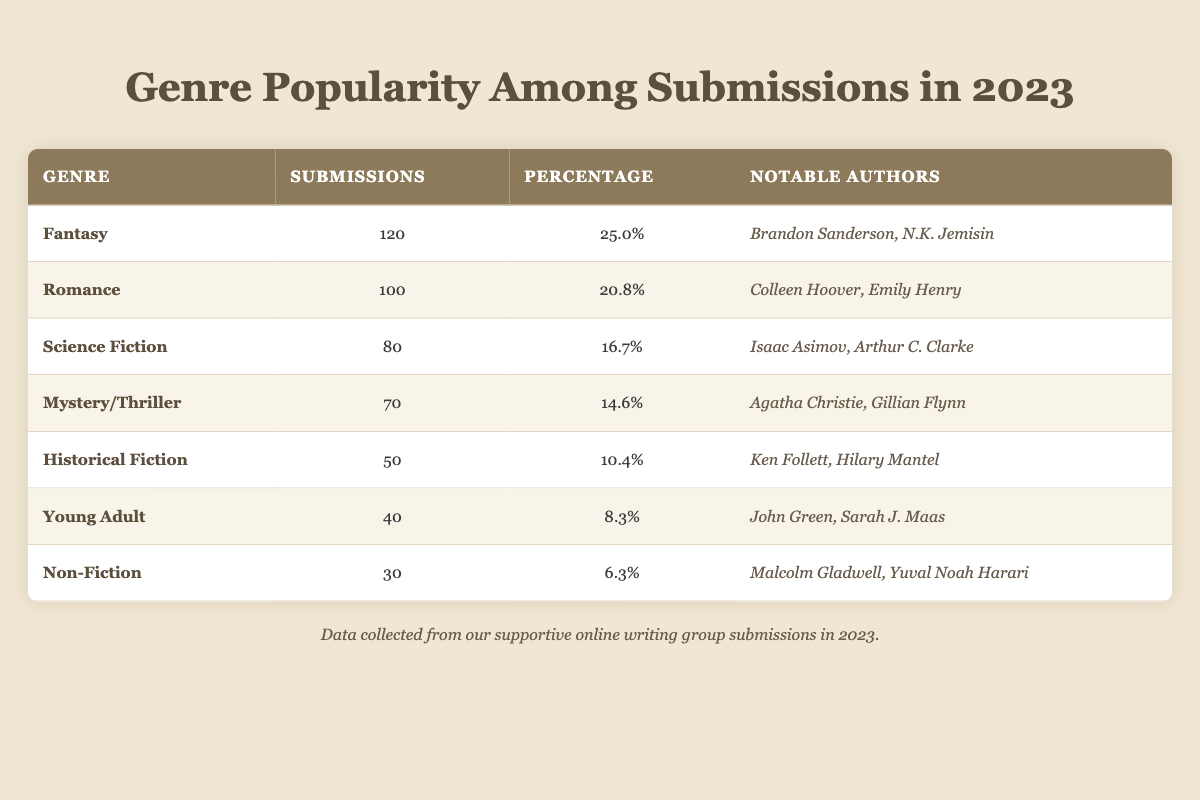What is the genre with the highest number of submissions? The table shows the number of submissions for each genre, with Fantasy at the top with 120 submissions.
Answer: Fantasy What percentage of total submissions does Science Fiction represent? Science Fiction has 80 submissions, which is 16.7% of the total submissions (480).
Answer: 16.7% Is Romance more popular than Mystery/Thriller in terms of submissions? Romance has 100 submissions while Mystery/Thriller has 70, so Romance is indeed more popular.
Answer: Yes What is the total number of submissions for the genres Historical Fiction, Young Adult, and Non-Fiction combined? The total is found by adding: 50 (Historical Fiction) + 40 (Young Adult) + 30 (Non-Fiction) = 120.
Answer: 120 Which genre has the lowest percentage of submissions? Non-Fiction has the lowest percentage at 6.3% of total submissions.
Answer: Non-Fiction How many more submissions does Fantasy have compared to Non-Fiction? Fantasy has 120 submissions and Non-Fiction has 30, so the difference is 120 - 30 = 90.
Answer: 90 Which notable authors are associated with Historical Fiction? The table lists Ken Follett and Hilary Mantel as notable authors for Historical Fiction.
Answer: Ken Follett, Hilary Mantel What percentage of total submissions does the sum of submissions for Young Adult and Non-Fiction represent? Young Adult has 40 and Non-Fiction has 30 submissions. Their total is 70, which represents (70/480) * 100 = 14.6%.
Answer: 14.6% Which genres have submissions equal to or above 70? The genres with submissions equal to or above 70 are Fantasy, Romance, Science Fiction, and Mystery/Thriller.
Answer: Fantasy, Romance, Science Fiction, Mystery/Thriller What fraction of the total submissions does Romance represent, in simplest terms? Romance has 100 submissions out of a total of 480, which simplifies to 100/480 or 5/24 when divided by 20.
Answer: 5/24 